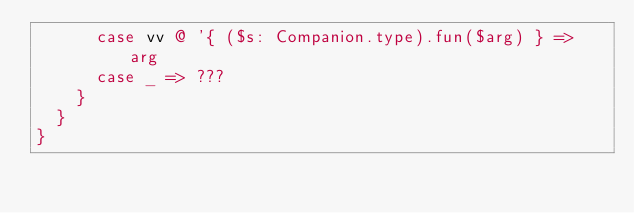<code> <loc_0><loc_0><loc_500><loc_500><_Scala_>      case vv @ '{ ($s: Companion.type).fun($arg) } => arg
      case _ => ???
    }
  }
}
</code> 